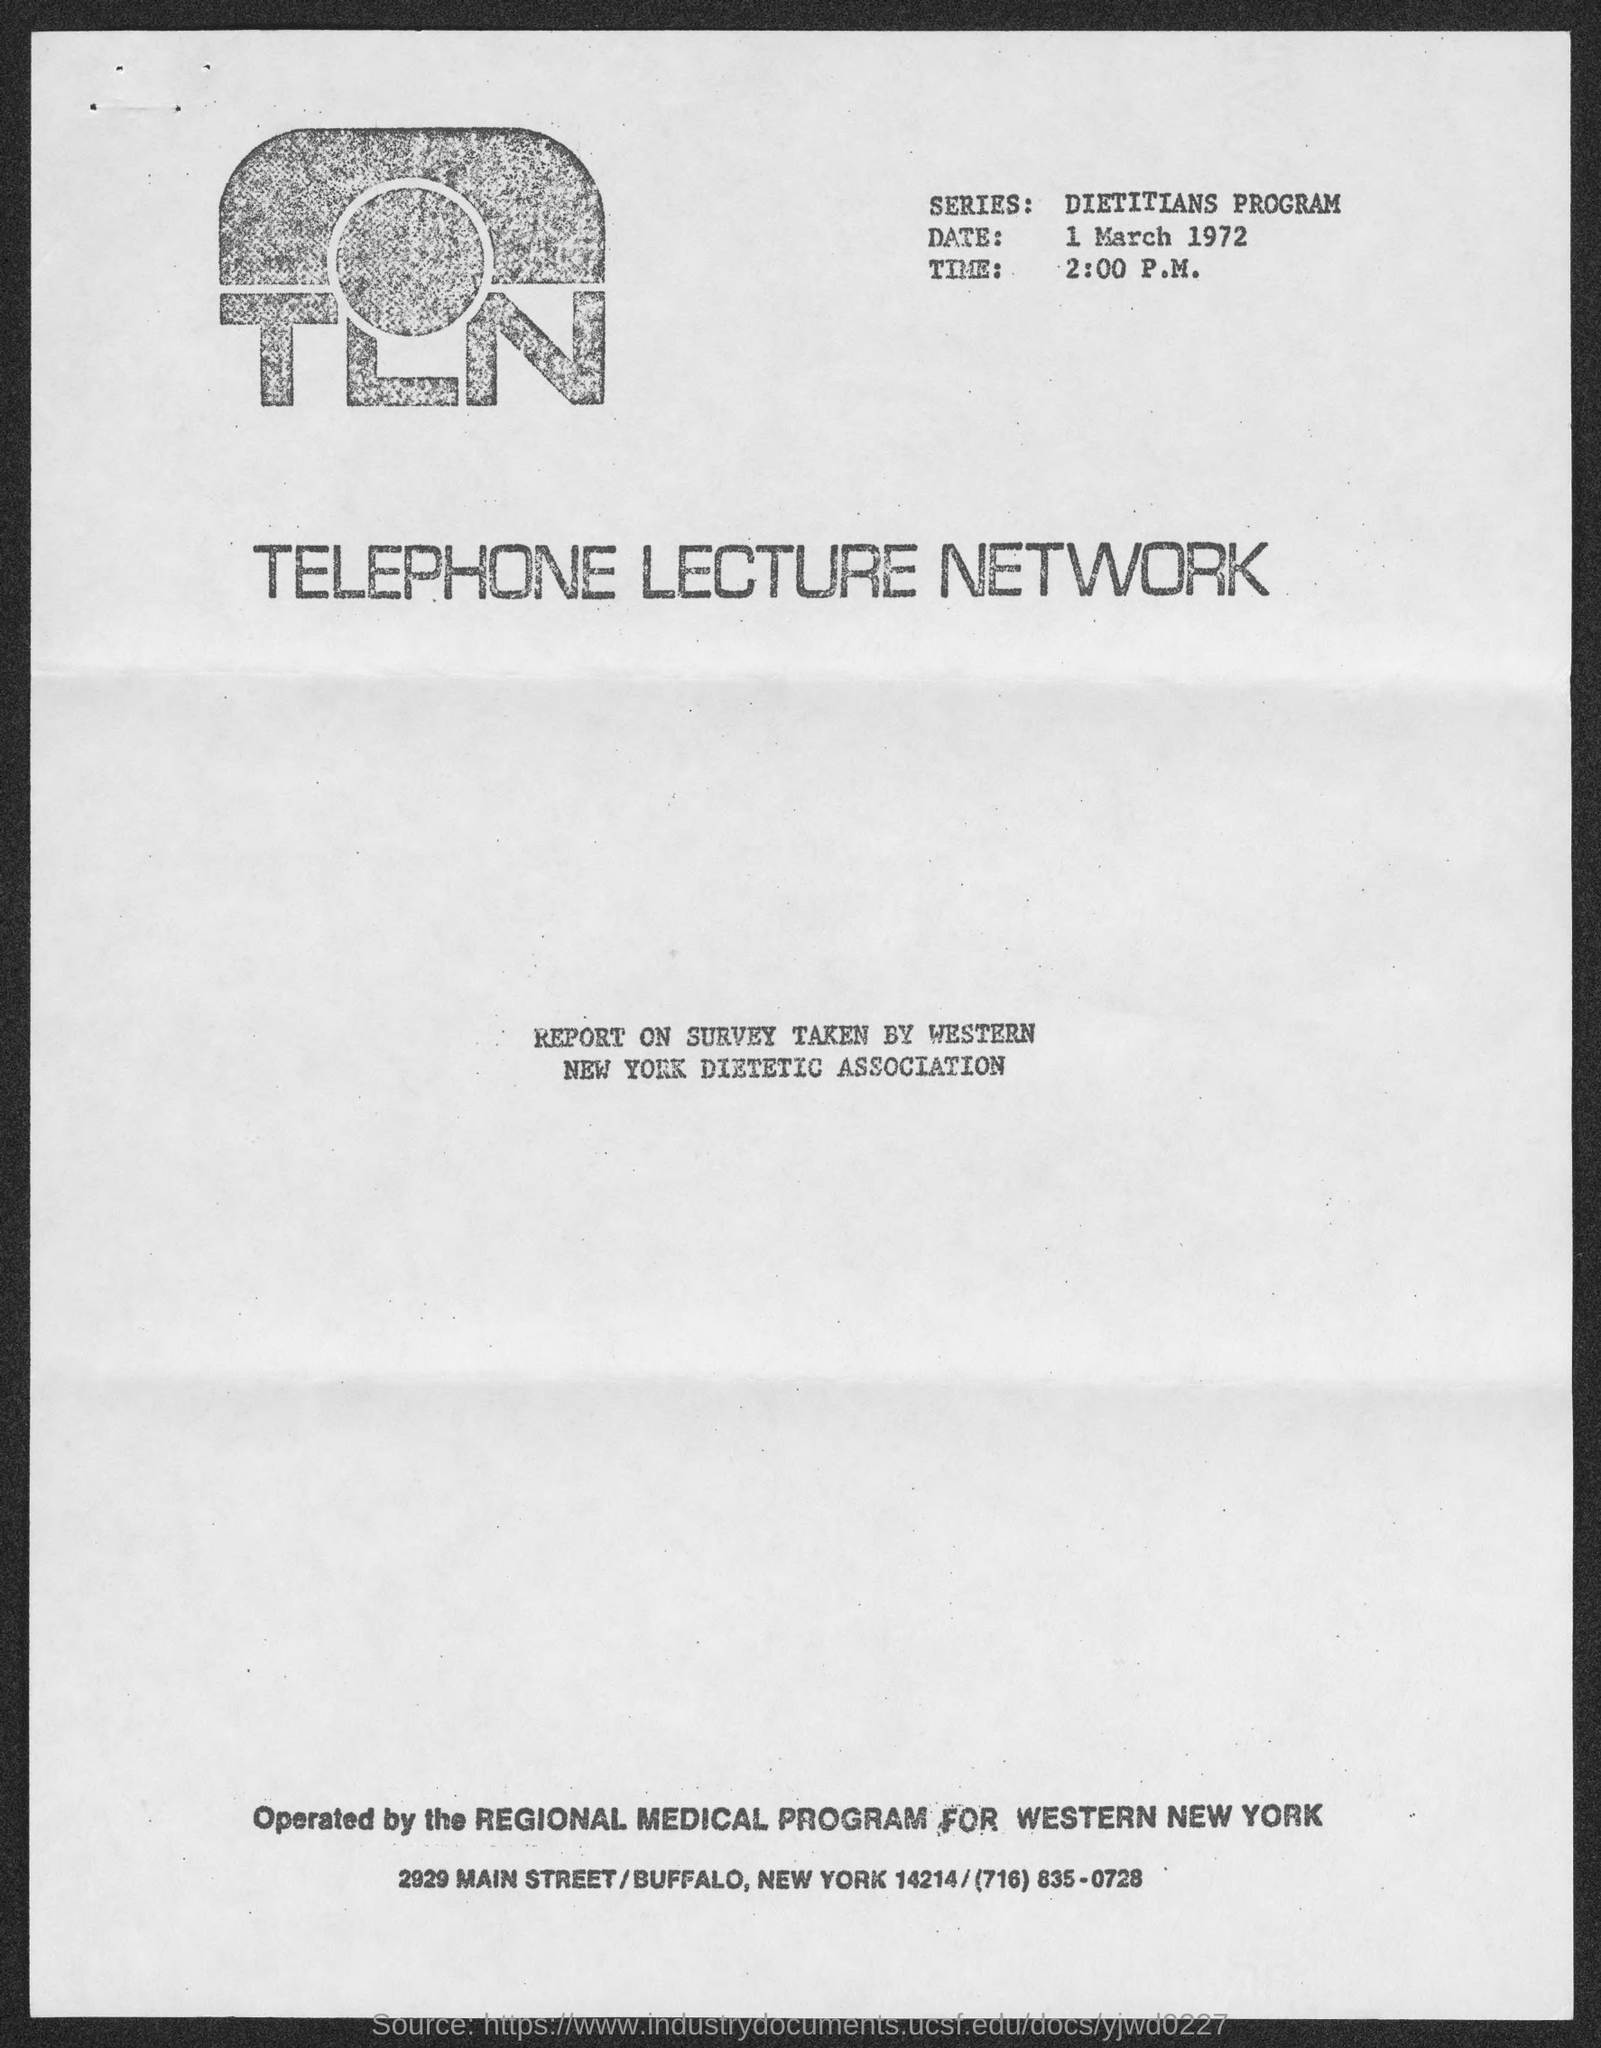What is the series name?
Give a very brief answer. Dietitians Program. What is the date at top of the page?
Ensure brevity in your answer.  1 march 1972. What is the time beside logo?
Your answer should be very brief. 2:00 P.M. 